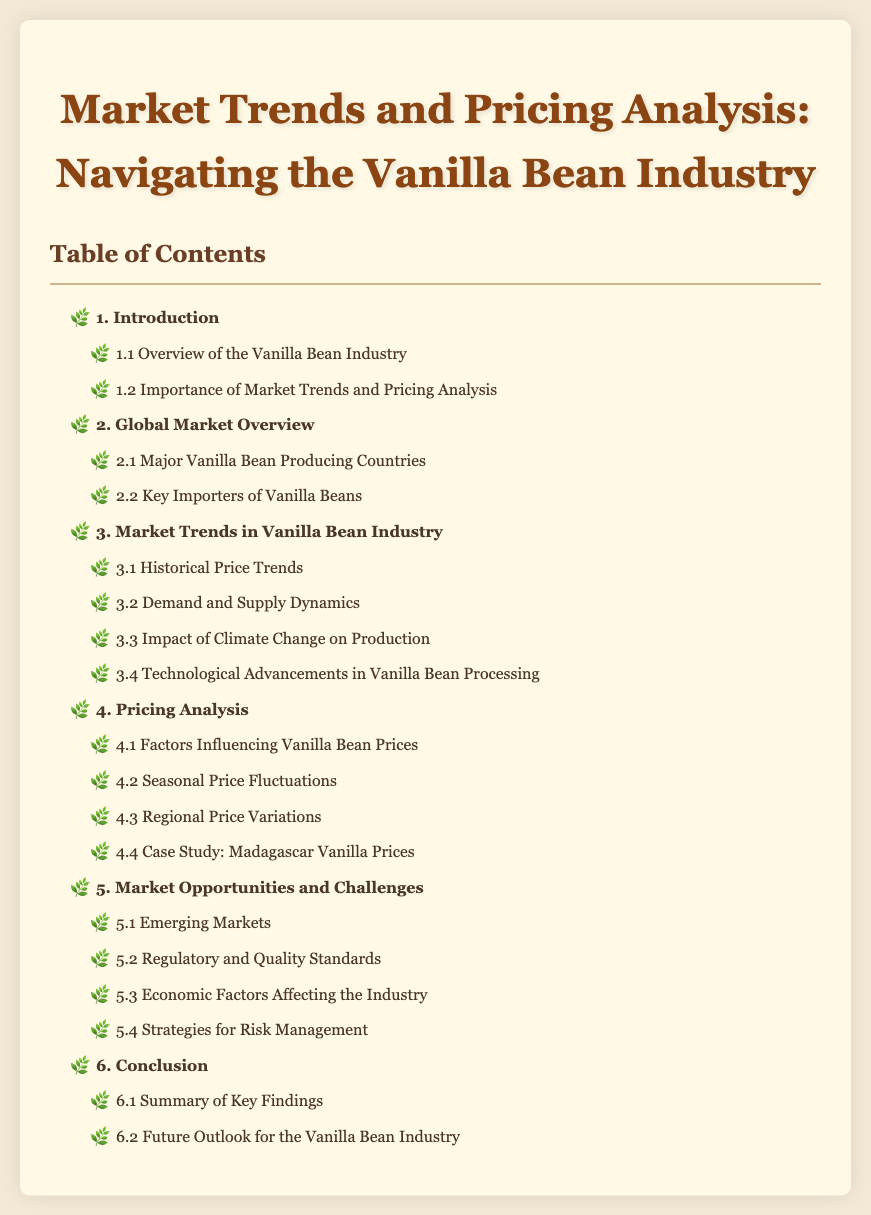What is the title of the document? The title is prominently displayed at the top of the document.
Answer: Market Trends and Pricing Analysis: Navigating the Vanilla Bean Industry What major section discusses historical price trends? This information can be found under the third chapter titled Market Trends in Vanilla Bean Industry.
Answer: 3.1 Historical Price Trends How many chapters are listed in the table of contents? The total number of chapters includes all major sections identified in the document.
Answer: 6 Which country is highlighted in the pricing analysis case study? The document specifically mentions a case study related to pricing of vanilla beans.
Answer: Madagascar What section addresses the impact of climate change? This information is included in one of the subsections under Market Trends.
Answer: 3.3 Impact of Climate Change on Production What section covers regulatory and quality standards? This information is located under the chapter about Market Opportunities and Challenges.
Answer: 5.2 Regulatory and Quality Standards 